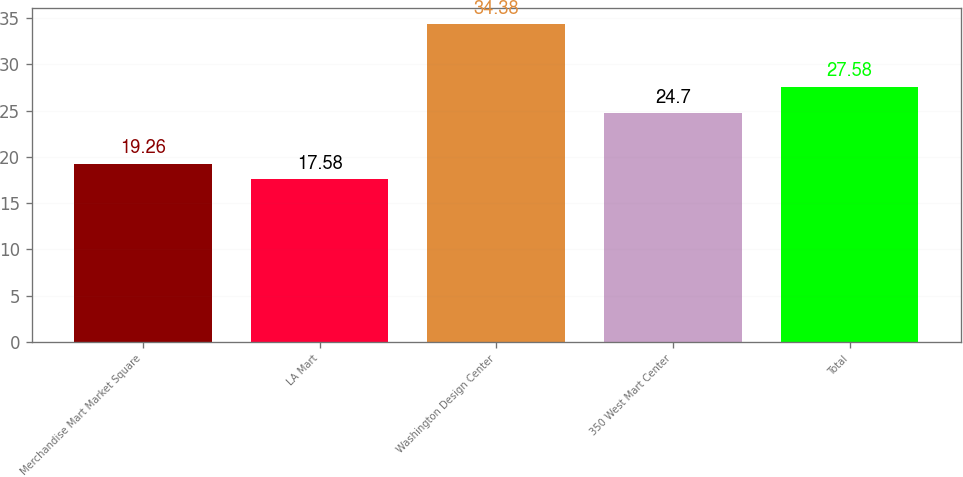<chart> <loc_0><loc_0><loc_500><loc_500><bar_chart><fcel>Merchandise Mart Market Square<fcel>LA Mart<fcel>Washington Design Center<fcel>350 West Mart Center<fcel>Total<nl><fcel>19.26<fcel>17.58<fcel>34.38<fcel>24.7<fcel>27.58<nl></chart> 